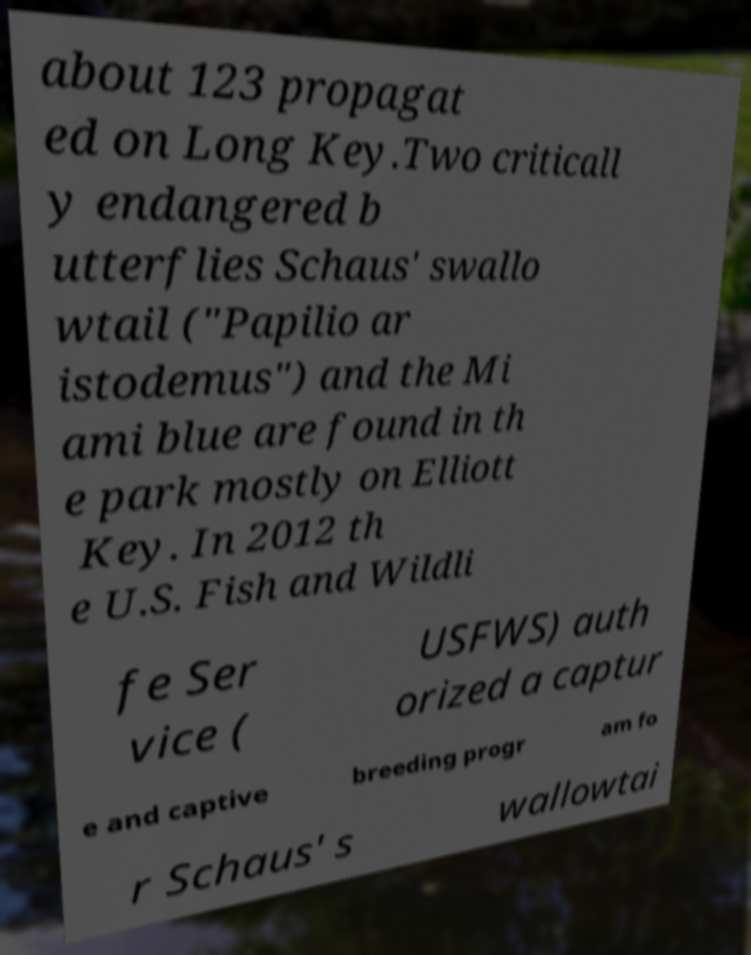Please identify and transcribe the text found in this image. about 123 propagat ed on Long Key.Two criticall y endangered b utterflies Schaus' swallo wtail ("Papilio ar istodemus") and the Mi ami blue are found in th e park mostly on Elliott Key. In 2012 th e U.S. Fish and Wildli fe Ser vice ( USFWS) auth orized a captur e and captive breeding progr am fo r Schaus' s wallowtai 